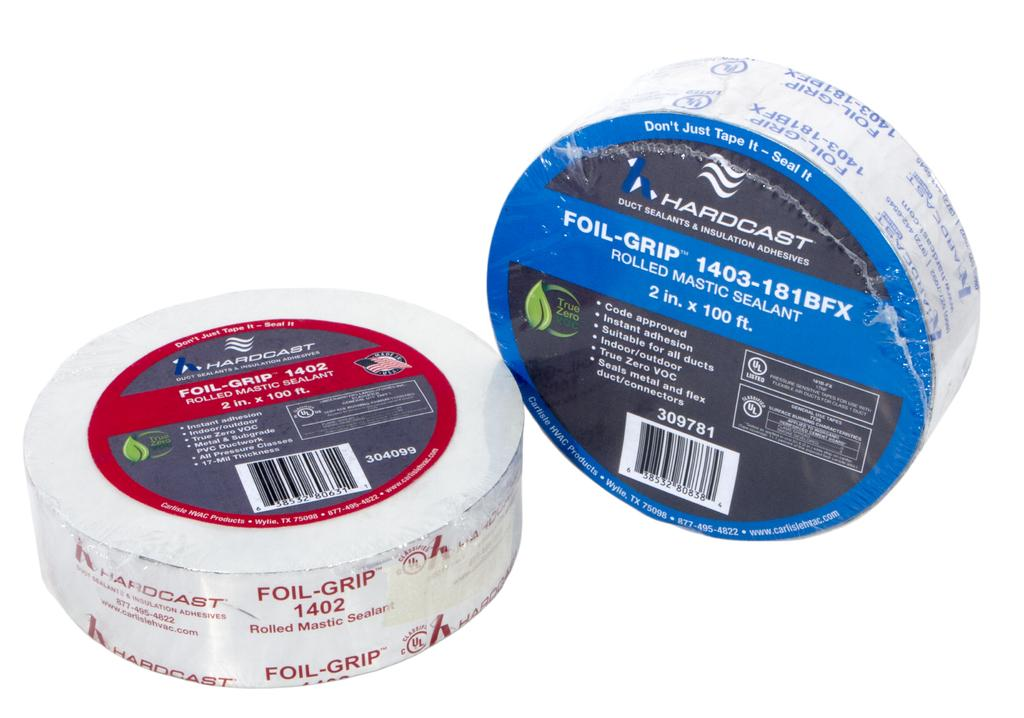How many sealants are visible in the image? There are two sealants in the image. What is the color of the surface on which the sealants are placed? The sealants are on a white surface. What type of cloth is draped over the sky in the image? There is no cloth or sky present in the image; it only features two sealants on a white surface. 